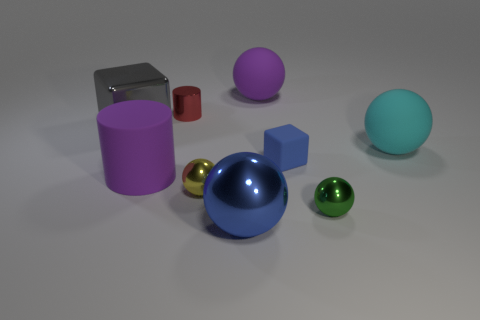If this were a real-life setup, what could be a possible use for these objects? If this arrangement were encountered in real life, the objects could potentially serve as educational tools in a classroom setting, specifically for lessons on geometry, material properties, and color theory. The varying sizes, shapes, and finishes could facilitate tactile and visual learning experiences for students. 